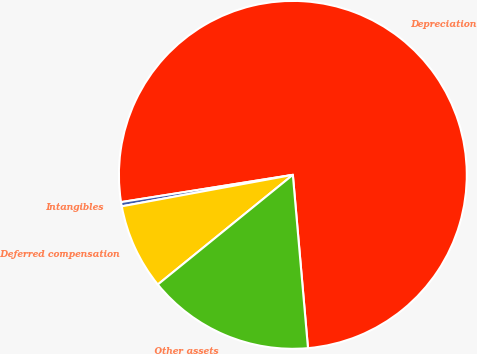<chart> <loc_0><loc_0><loc_500><loc_500><pie_chart><fcel>Depreciation<fcel>Intangibles<fcel>Deferred compensation<fcel>Other assets<nl><fcel>76.11%<fcel>0.39%<fcel>7.96%<fcel>15.53%<nl></chart> 